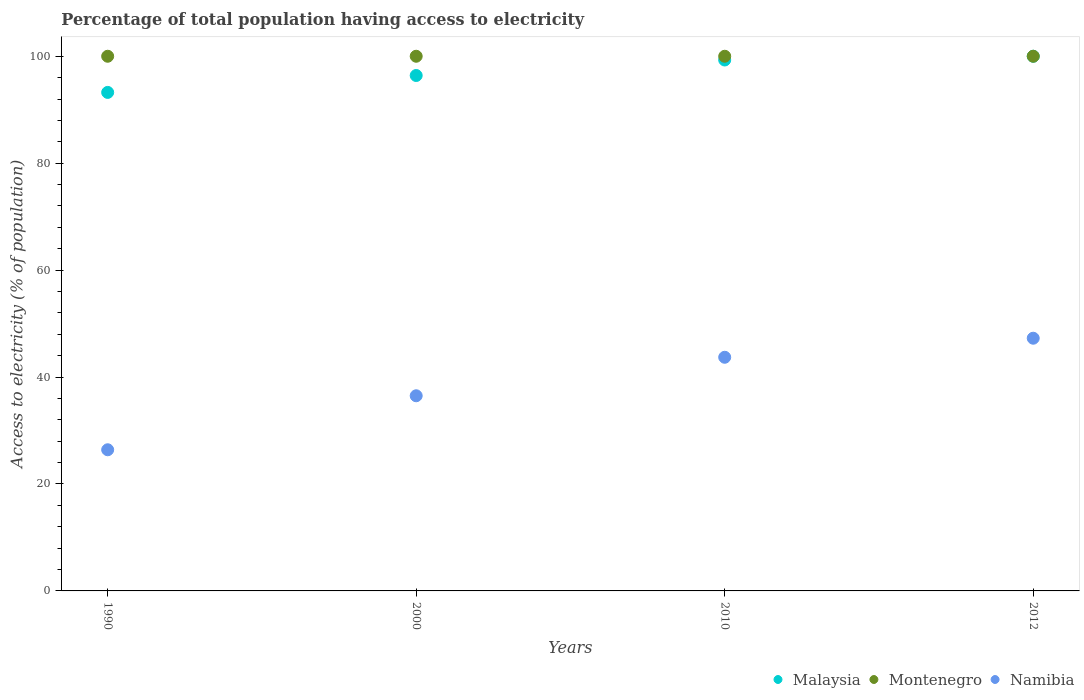How many different coloured dotlines are there?
Your answer should be compact. 3. Is the number of dotlines equal to the number of legend labels?
Provide a succinct answer. Yes. What is the percentage of population that have access to electricity in Namibia in 2010?
Your response must be concise. 43.7. Across all years, what is the minimum percentage of population that have access to electricity in Namibia?
Your response must be concise. 26.4. What is the total percentage of population that have access to electricity in Montenegro in the graph?
Your answer should be compact. 400. What is the difference between the percentage of population that have access to electricity in Namibia in 2000 and that in 2012?
Make the answer very short. -10.76. What is the average percentage of population that have access to electricity in Malaysia per year?
Give a very brief answer. 97.23. In the year 2012, what is the difference between the percentage of population that have access to electricity in Malaysia and percentage of population that have access to electricity in Namibia?
Keep it short and to the point. 52.74. What is the ratio of the percentage of population that have access to electricity in Namibia in 2000 to that in 2010?
Your answer should be very brief. 0.84. Is the difference between the percentage of population that have access to electricity in Malaysia in 2000 and 2012 greater than the difference between the percentage of population that have access to electricity in Namibia in 2000 and 2012?
Give a very brief answer. Yes. What is the difference between the highest and the second highest percentage of population that have access to electricity in Namibia?
Ensure brevity in your answer.  3.56. What is the difference between the highest and the lowest percentage of population that have access to electricity in Montenegro?
Ensure brevity in your answer.  0. Is the sum of the percentage of population that have access to electricity in Namibia in 1990 and 2012 greater than the maximum percentage of population that have access to electricity in Malaysia across all years?
Give a very brief answer. No. Is it the case that in every year, the sum of the percentage of population that have access to electricity in Montenegro and percentage of population that have access to electricity in Malaysia  is greater than the percentage of population that have access to electricity in Namibia?
Your response must be concise. Yes. Does the percentage of population that have access to electricity in Montenegro monotonically increase over the years?
Offer a terse response. No. Is the percentage of population that have access to electricity in Montenegro strictly less than the percentage of population that have access to electricity in Malaysia over the years?
Provide a succinct answer. No. How many years are there in the graph?
Your answer should be very brief. 4. Does the graph contain grids?
Ensure brevity in your answer.  No. Where does the legend appear in the graph?
Your response must be concise. Bottom right. How many legend labels are there?
Make the answer very short. 3. What is the title of the graph?
Offer a terse response. Percentage of total population having access to electricity. What is the label or title of the X-axis?
Ensure brevity in your answer.  Years. What is the label or title of the Y-axis?
Your response must be concise. Access to electricity (% of population). What is the Access to electricity (% of population) of Malaysia in 1990?
Ensure brevity in your answer.  93.24. What is the Access to electricity (% of population) in Montenegro in 1990?
Make the answer very short. 100. What is the Access to electricity (% of population) of Namibia in 1990?
Give a very brief answer. 26.4. What is the Access to electricity (% of population) of Malaysia in 2000?
Your response must be concise. 96.4. What is the Access to electricity (% of population) of Montenegro in 2000?
Provide a succinct answer. 100. What is the Access to electricity (% of population) of Namibia in 2000?
Your answer should be very brief. 36.5. What is the Access to electricity (% of population) in Malaysia in 2010?
Your answer should be compact. 99.3. What is the Access to electricity (% of population) in Namibia in 2010?
Your answer should be very brief. 43.7. What is the Access to electricity (% of population) of Montenegro in 2012?
Ensure brevity in your answer.  100. What is the Access to electricity (% of population) of Namibia in 2012?
Your answer should be compact. 47.26. Across all years, what is the maximum Access to electricity (% of population) of Malaysia?
Ensure brevity in your answer.  100. Across all years, what is the maximum Access to electricity (% of population) of Namibia?
Ensure brevity in your answer.  47.26. Across all years, what is the minimum Access to electricity (% of population) of Malaysia?
Your answer should be very brief. 93.24. Across all years, what is the minimum Access to electricity (% of population) in Namibia?
Ensure brevity in your answer.  26.4. What is the total Access to electricity (% of population) of Malaysia in the graph?
Ensure brevity in your answer.  388.94. What is the total Access to electricity (% of population) of Montenegro in the graph?
Keep it short and to the point. 400. What is the total Access to electricity (% of population) of Namibia in the graph?
Keep it short and to the point. 153.86. What is the difference between the Access to electricity (% of population) of Malaysia in 1990 and that in 2000?
Your answer should be compact. -3.16. What is the difference between the Access to electricity (% of population) of Montenegro in 1990 and that in 2000?
Provide a succinct answer. 0. What is the difference between the Access to electricity (% of population) of Malaysia in 1990 and that in 2010?
Ensure brevity in your answer.  -6.06. What is the difference between the Access to electricity (% of population) in Montenegro in 1990 and that in 2010?
Make the answer very short. 0. What is the difference between the Access to electricity (% of population) in Namibia in 1990 and that in 2010?
Make the answer very short. -17.3. What is the difference between the Access to electricity (% of population) in Malaysia in 1990 and that in 2012?
Keep it short and to the point. -6.76. What is the difference between the Access to electricity (% of population) in Namibia in 1990 and that in 2012?
Ensure brevity in your answer.  -20.86. What is the difference between the Access to electricity (% of population) in Montenegro in 2000 and that in 2010?
Provide a short and direct response. 0. What is the difference between the Access to electricity (% of population) in Namibia in 2000 and that in 2010?
Your answer should be compact. -7.2. What is the difference between the Access to electricity (% of population) of Montenegro in 2000 and that in 2012?
Ensure brevity in your answer.  0. What is the difference between the Access to electricity (% of population) of Namibia in 2000 and that in 2012?
Keep it short and to the point. -10.76. What is the difference between the Access to electricity (% of population) in Montenegro in 2010 and that in 2012?
Offer a very short reply. 0. What is the difference between the Access to electricity (% of population) in Namibia in 2010 and that in 2012?
Keep it short and to the point. -3.56. What is the difference between the Access to electricity (% of population) in Malaysia in 1990 and the Access to electricity (% of population) in Montenegro in 2000?
Give a very brief answer. -6.76. What is the difference between the Access to electricity (% of population) of Malaysia in 1990 and the Access to electricity (% of population) of Namibia in 2000?
Provide a succinct answer. 56.74. What is the difference between the Access to electricity (% of population) of Montenegro in 1990 and the Access to electricity (% of population) of Namibia in 2000?
Offer a very short reply. 63.5. What is the difference between the Access to electricity (% of population) of Malaysia in 1990 and the Access to electricity (% of population) of Montenegro in 2010?
Ensure brevity in your answer.  -6.76. What is the difference between the Access to electricity (% of population) of Malaysia in 1990 and the Access to electricity (% of population) of Namibia in 2010?
Provide a short and direct response. 49.54. What is the difference between the Access to electricity (% of population) of Montenegro in 1990 and the Access to electricity (% of population) of Namibia in 2010?
Your answer should be compact. 56.3. What is the difference between the Access to electricity (% of population) in Malaysia in 1990 and the Access to electricity (% of population) in Montenegro in 2012?
Ensure brevity in your answer.  -6.76. What is the difference between the Access to electricity (% of population) of Malaysia in 1990 and the Access to electricity (% of population) of Namibia in 2012?
Your answer should be very brief. 45.98. What is the difference between the Access to electricity (% of population) of Montenegro in 1990 and the Access to electricity (% of population) of Namibia in 2012?
Provide a short and direct response. 52.74. What is the difference between the Access to electricity (% of population) of Malaysia in 2000 and the Access to electricity (% of population) of Montenegro in 2010?
Keep it short and to the point. -3.6. What is the difference between the Access to electricity (% of population) of Malaysia in 2000 and the Access to electricity (% of population) of Namibia in 2010?
Ensure brevity in your answer.  52.7. What is the difference between the Access to electricity (% of population) in Montenegro in 2000 and the Access to electricity (% of population) in Namibia in 2010?
Offer a terse response. 56.3. What is the difference between the Access to electricity (% of population) in Malaysia in 2000 and the Access to electricity (% of population) in Namibia in 2012?
Keep it short and to the point. 49.14. What is the difference between the Access to electricity (% of population) in Montenegro in 2000 and the Access to electricity (% of population) in Namibia in 2012?
Keep it short and to the point. 52.74. What is the difference between the Access to electricity (% of population) of Malaysia in 2010 and the Access to electricity (% of population) of Montenegro in 2012?
Offer a terse response. -0.7. What is the difference between the Access to electricity (% of population) in Malaysia in 2010 and the Access to electricity (% of population) in Namibia in 2012?
Your response must be concise. 52.04. What is the difference between the Access to electricity (% of population) in Montenegro in 2010 and the Access to electricity (% of population) in Namibia in 2012?
Offer a very short reply. 52.74. What is the average Access to electricity (% of population) of Malaysia per year?
Give a very brief answer. 97.23. What is the average Access to electricity (% of population) in Namibia per year?
Your answer should be very brief. 38.47. In the year 1990, what is the difference between the Access to electricity (% of population) of Malaysia and Access to electricity (% of population) of Montenegro?
Make the answer very short. -6.76. In the year 1990, what is the difference between the Access to electricity (% of population) in Malaysia and Access to electricity (% of population) in Namibia?
Your answer should be compact. 66.84. In the year 1990, what is the difference between the Access to electricity (% of population) of Montenegro and Access to electricity (% of population) of Namibia?
Offer a terse response. 73.6. In the year 2000, what is the difference between the Access to electricity (% of population) in Malaysia and Access to electricity (% of population) in Montenegro?
Your answer should be compact. -3.6. In the year 2000, what is the difference between the Access to electricity (% of population) of Malaysia and Access to electricity (% of population) of Namibia?
Your answer should be very brief. 59.9. In the year 2000, what is the difference between the Access to electricity (% of population) of Montenegro and Access to electricity (% of population) of Namibia?
Make the answer very short. 63.5. In the year 2010, what is the difference between the Access to electricity (% of population) of Malaysia and Access to electricity (% of population) of Namibia?
Keep it short and to the point. 55.6. In the year 2010, what is the difference between the Access to electricity (% of population) of Montenegro and Access to electricity (% of population) of Namibia?
Offer a very short reply. 56.3. In the year 2012, what is the difference between the Access to electricity (% of population) of Malaysia and Access to electricity (% of population) of Namibia?
Your answer should be very brief. 52.74. In the year 2012, what is the difference between the Access to electricity (% of population) in Montenegro and Access to electricity (% of population) in Namibia?
Give a very brief answer. 52.74. What is the ratio of the Access to electricity (% of population) in Malaysia in 1990 to that in 2000?
Provide a short and direct response. 0.97. What is the ratio of the Access to electricity (% of population) of Montenegro in 1990 to that in 2000?
Offer a terse response. 1. What is the ratio of the Access to electricity (% of population) of Namibia in 1990 to that in 2000?
Offer a terse response. 0.72. What is the ratio of the Access to electricity (% of population) of Malaysia in 1990 to that in 2010?
Offer a very short reply. 0.94. What is the ratio of the Access to electricity (% of population) of Montenegro in 1990 to that in 2010?
Provide a succinct answer. 1. What is the ratio of the Access to electricity (% of population) in Namibia in 1990 to that in 2010?
Your response must be concise. 0.6. What is the ratio of the Access to electricity (% of population) in Malaysia in 1990 to that in 2012?
Offer a very short reply. 0.93. What is the ratio of the Access to electricity (% of population) of Montenegro in 1990 to that in 2012?
Your response must be concise. 1. What is the ratio of the Access to electricity (% of population) in Namibia in 1990 to that in 2012?
Offer a very short reply. 0.56. What is the ratio of the Access to electricity (% of population) of Malaysia in 2000 to that in 2010?
Keep it short and to the point. 0.97. What is the ratio of the Access to electricity (% of population) in Montenegro in 2000 to that in 2010?
Your answer should be very brief. 1. What is the ratio of the Access to electricity (% of population) in Namibia in 2000 to that in 2010?
Your answer should be very brief. 0.84. What is the ratio of the Access to electricity (% of population) in Namibia in 2000 to that in 2012?
Provide a short and direct response. 0.77. What is the ratio of the Access to electricity (% of population) in Malaysia in 2010 to that in 2012?
Ensure brevity in your answer.  0.99. What is the ratio of the Access to electricity (% of population) of Namibia in 2010 to that in 2012?
Give a very brief answer. 0.92. What is the difference between the highest and the second highest Access to electricity (% of population) in Malaysia?
Your answer should be compact. 0.7. What is the difference between the highest and the second highest Access to electricity (% of population) in Montenegro?
Give a very brief answer. 0. What is the difference between the highest and the second highest Access to electricity (% of population) of Namibia?
Provide a succinct answer. 3.56. What is the difference between the highest and the lowest Access to electricity (% of population) of Malaysia?
Your response must be concise. 6.76. What is the difference between the highest and the lowest Access to electricity (% of population) in Namibia?
Provide a succinct answer. 20.86. 